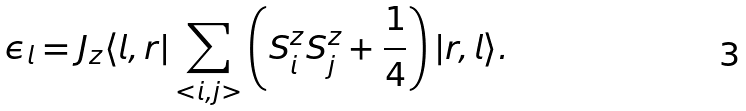<formula> <loc_0><loc_0><loc_500><loc_500>\epsilon _ { l } = J _ { z } \langle l , { r } | \sum _ { < i , j > } \left ( S _ { i } ^ { z } S _ { j } ^ { z } + \frac { 1 } { 4 } \right ) | { r } , l \rangle .</formula> 